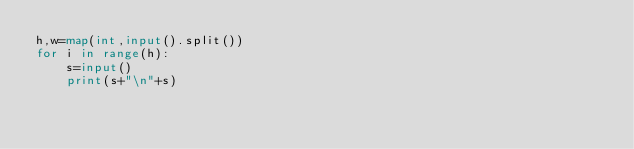Convert code to text. <code><loc_0><loc_0><loc_500><loc_500><_Python_>h,w=map(int,input().split())
for i in range(h):
    s=input()
    print(s+"\n"+s)</code> 